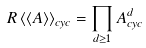<formula> <loc_0><loc_0><loc_500><loc_500>R \left < \left < A \right > \right > _ { c y c } = \prod _ { d \geq 1 } A ^ { d } _ { c y c }</formula> 